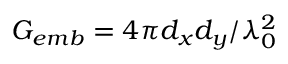<formula> <loc_0><loc_0><loc_500><loc_500>G _ { e m b } = 4 \pi d _ { x } d _ { y } / \lambda _ { 0 } ^ { 2 }</formula> 